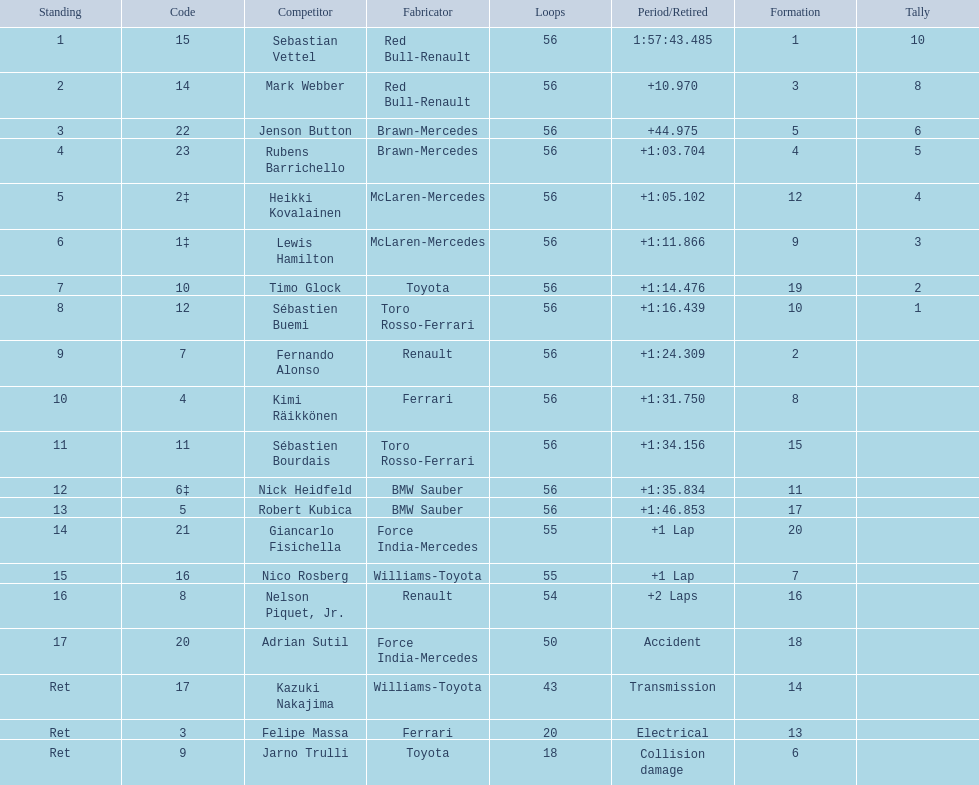Which drive retired because of electrical issues? Felipe Massa. Which driver retired due to accident? Adrian Sutil. Which driver retired due to collision damage? Jarno Trulli. 